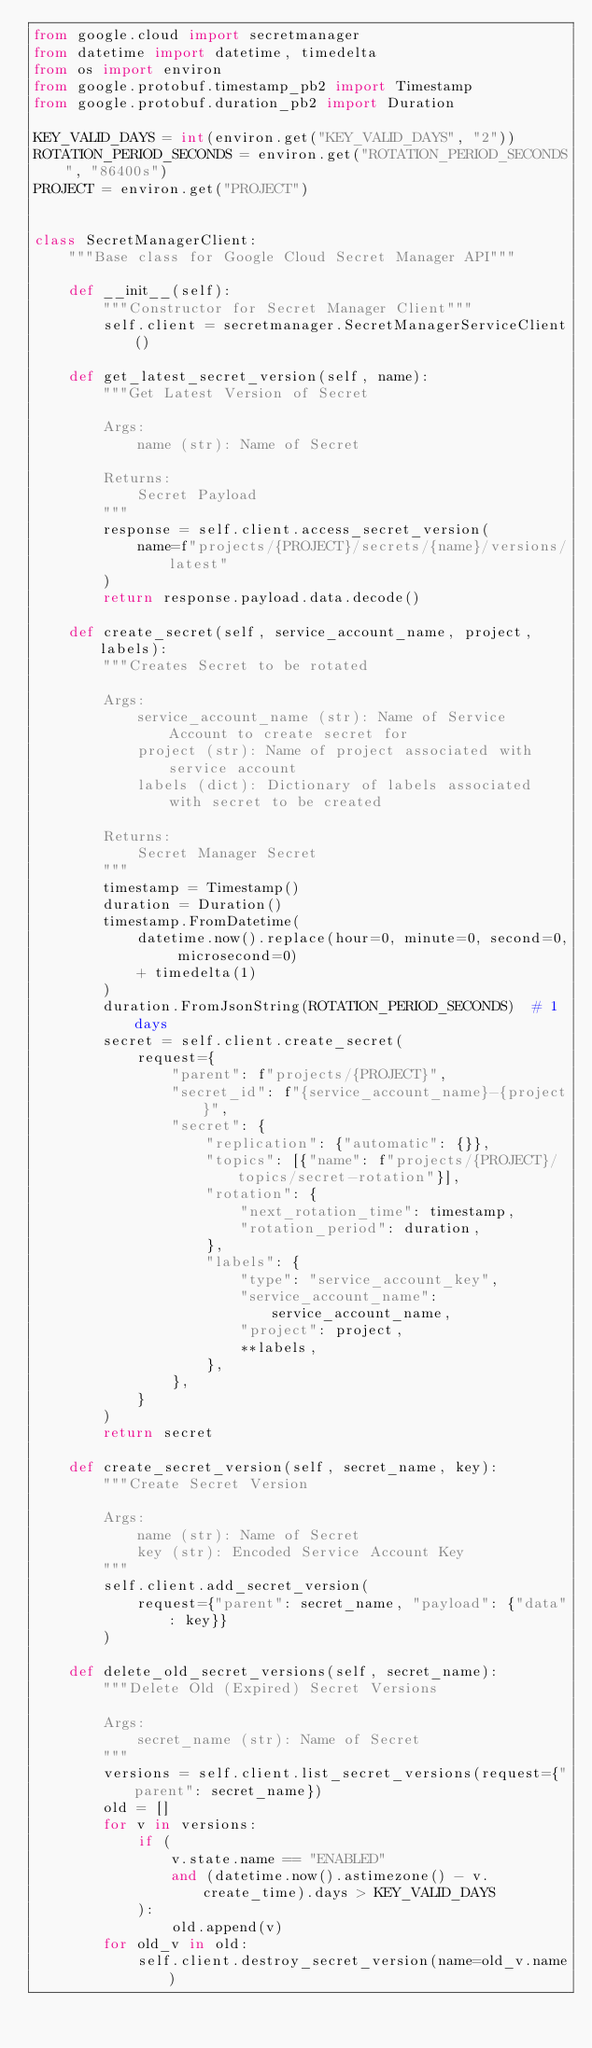<code> <loc_0><loc_0><loc_500><loc_500><_Python_>from google.cloud import secretmanager
from datetime import datetime, timedelta
from os import environ
from google.protobuf.timestamp_pb2 import Timestamp
from google.protobuf.duration_pb2 import Duration

KEY_VALID_DAYS = int(environ.get("KEY_VALID_DAYS", "2"))
ROTATION_PERIOD_SECONDS = environ.get("ROTATION_PERIOD_SECONDS", "86400s")
PROJECT = environ.get("PROJECT")


class SecretManagerClient:
    """Base class for Google Cloud Secret Manager API"""

    def __init__(self):
        """Constructor for Secret Manager Client"""
        self.client = secretmanager.SecretManagerServiceClient()

    def get_latest_secret_version(self, name):
        """Get Latest Version of Secret

        Args:
            name (str): Name of Secret

        Returns:
            Secret Payload
        """
        response = self.client.access_secret_version(
            name=f"projects/{PROJECT}/secrets/{name}/versions/latest"
        )
        return response.payload.data.decode()

    def create_secret(self, service_account_name, project, labels):
        """Creates Secret to be rotated

        Args:
            service_account_name (str): Name of Service Account to create secret for
            project (str): Name of project associated with service account
            labels (dict): Dictionary of labels associated with secret to be created

        Returns:
            Secret Manager Secret
        """
        timestamp = Timestamp()
        duration = Duration()
        timestamp.FromDatetime(
            datetime.now().replace(hour=0, minute=0, second=0, microsecond=0)
            + timedelta(1)
        )
        duration.FromJsonString(ROTATION_PERIOD_SECONDS)  # 1 days
        secret = self.client.create_secret(
            request={
                "parent": f"projects/{PROJECT}",
                "secret_id": f"{service_account_name}-{project}",
                "secret": {
                    "replication": {"automatic": {}},
                    "topics": [{"name": f"projects/{PROJECT}/topics/secret-rotation"}],
                    "rotation": {
                        "next_rotation_time": timestamp,
                        "rotation_period": duration,
                    },
                    "labels": {
                        "type": "service_account_key",
                        "service_account_name": service_account_name,
                        "project": project,
                        **labels,
                    },
                },
            }
        )
        return secret

    def create_secret_version(self, secret_name, key):
        """Create Secret Version

        Args:
            name (str): Name of Secret
            key (str): Encoded Service Account Key
        """
        self.client.add_secret_version(
            request={"parent": secret_name, "payload": {"data": key}}
        )

    def delete_old_secret_versions(self, secret_name):
        """Delete Old (Expired) Secret Versions

        Args:
            secret_name (str): Name of Secret
        """
        versions = self.client.list_secret_versions(request={"parent": secret_name})
        old = []
        for v in versions:
            if (
                v.state.name == "ENABLED"
                and (datetime.now().astimezone() - v.create_time).days > KEY_VALID_DAYS
            ):
                old.append(v)
        for old_v in old:
            self.client.destroy_secret_version(name=old_v.name)
</code> 